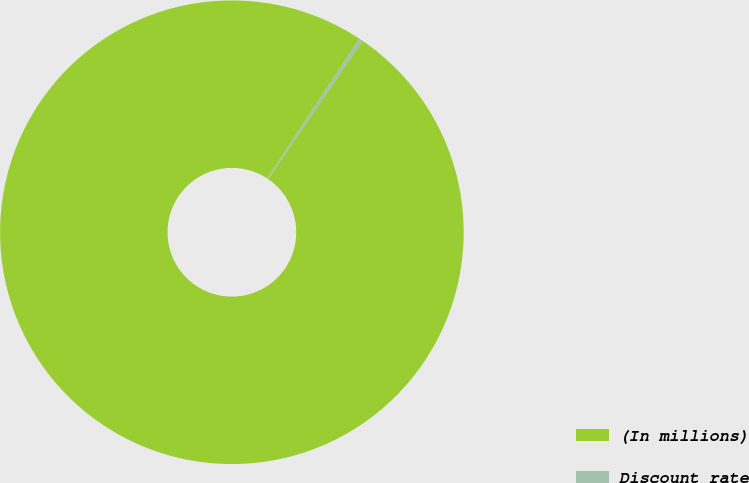Convert chart to OTSL. <chart><loc_0><loc_0><loc_500><loc_500><pie_chart><fcel>(In millions)<fcel>Discount rate<nl><fcel>99.74%<fcel>0.26%<nl></chart> 